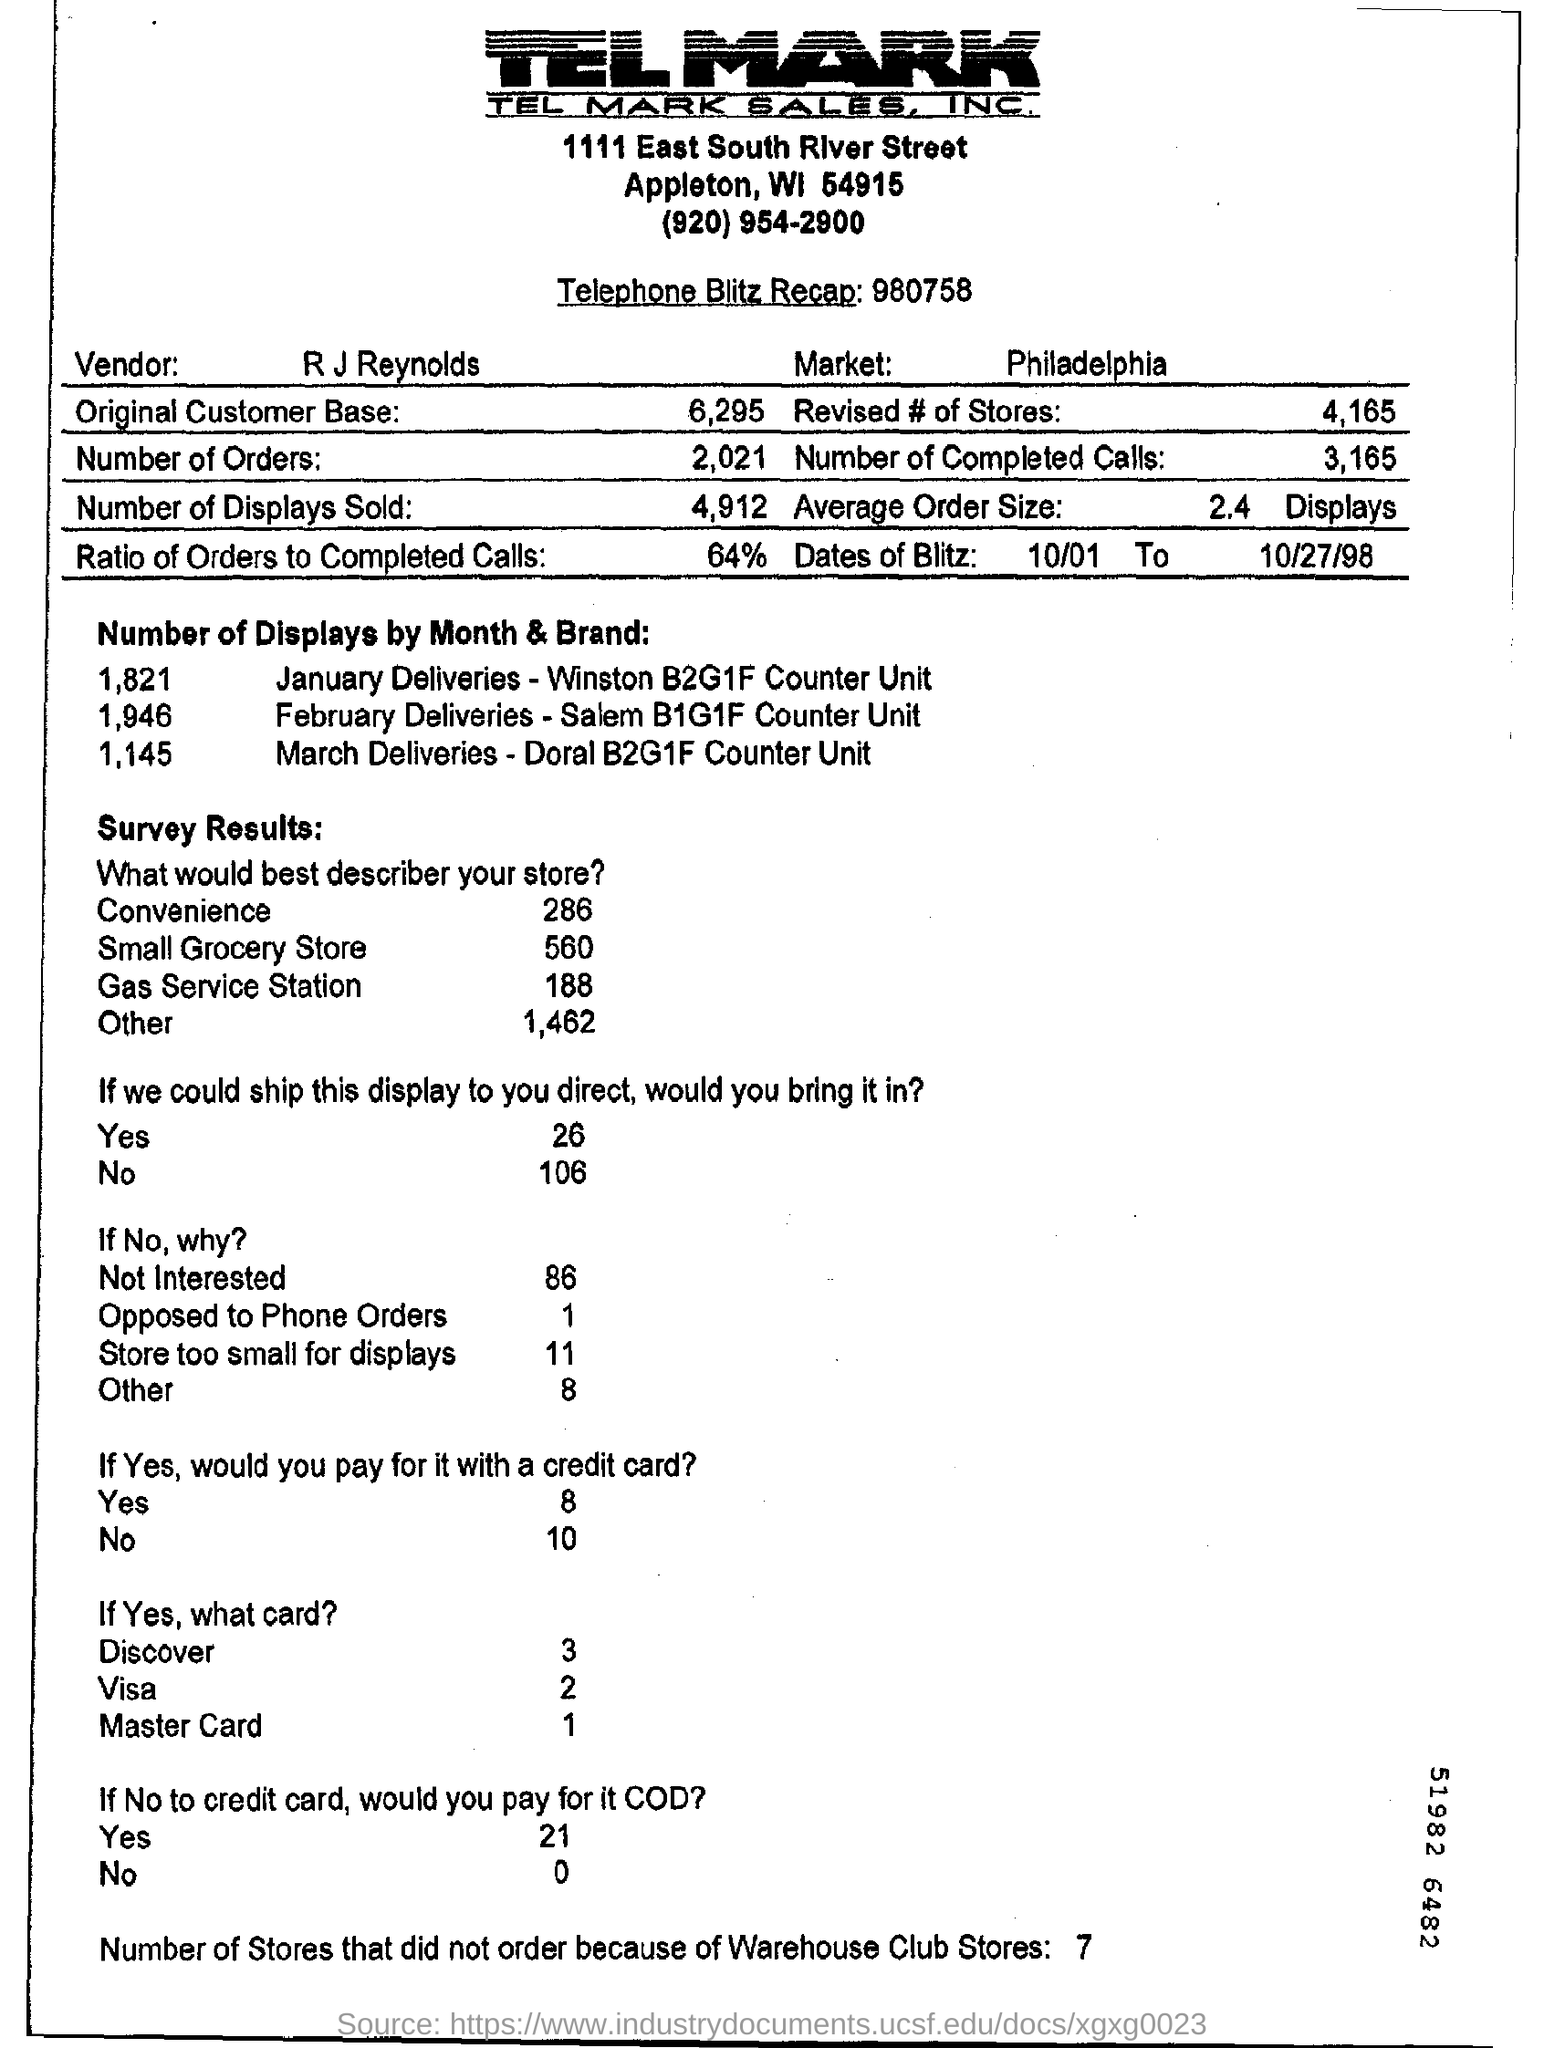How many number of stores that did not order because of Warehouse club stores?
Give a very brief answer. 7. How many number of deliveries are there in the month of march
Your response must be concise. 1,145. What is the name of the vendor?
Provide a succinct answer. R J Reynolds. What is name of the market?
Your answer should be compact. Philadelphia. What is the ratio of orders to completed cells?
Your answer should be compact. 64%. 